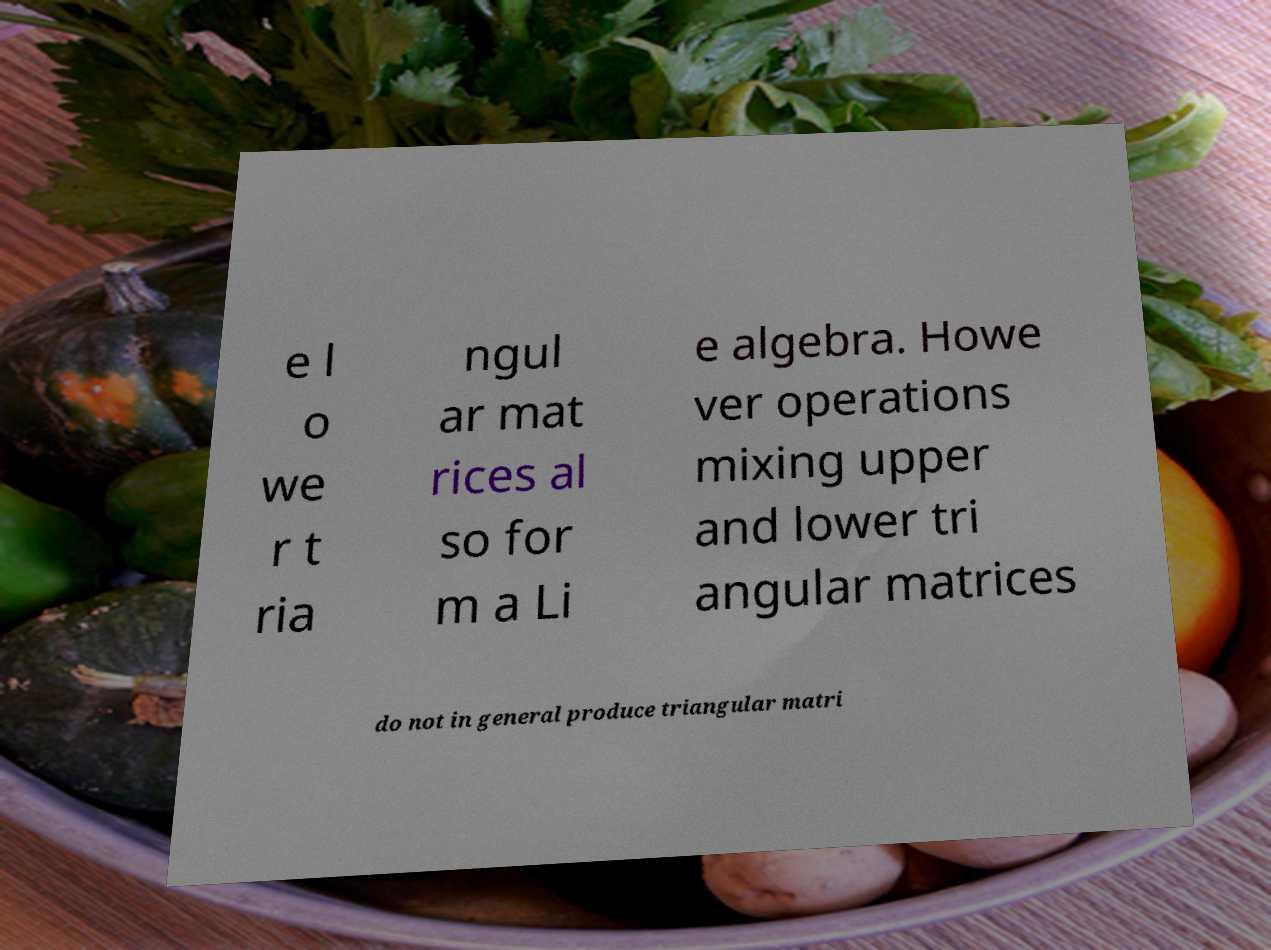Can you accurately transcribe the text from the provided image for me? e l o we r t ria ngul ar mat rices al so for m a Li e algebra. Howe ver operations mixing upper and lower tri angular matrices do not in general produce triangular matri 